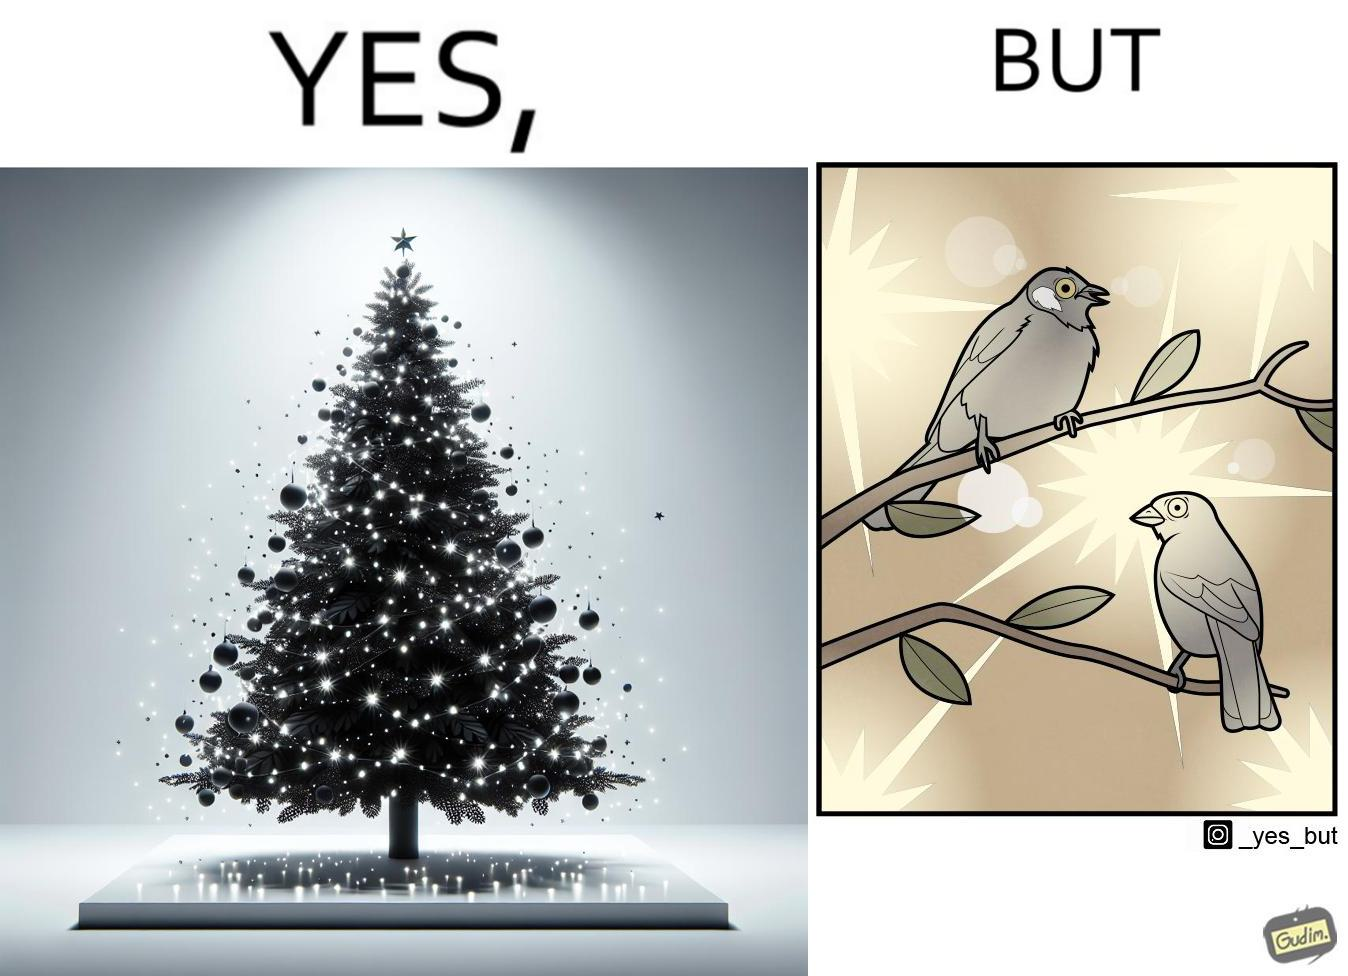Describe what you see in the left and right parts of this image. In the left part of the image: A tree decorated with lights all over it In the right part of the image: Birds dazzled by many lights 